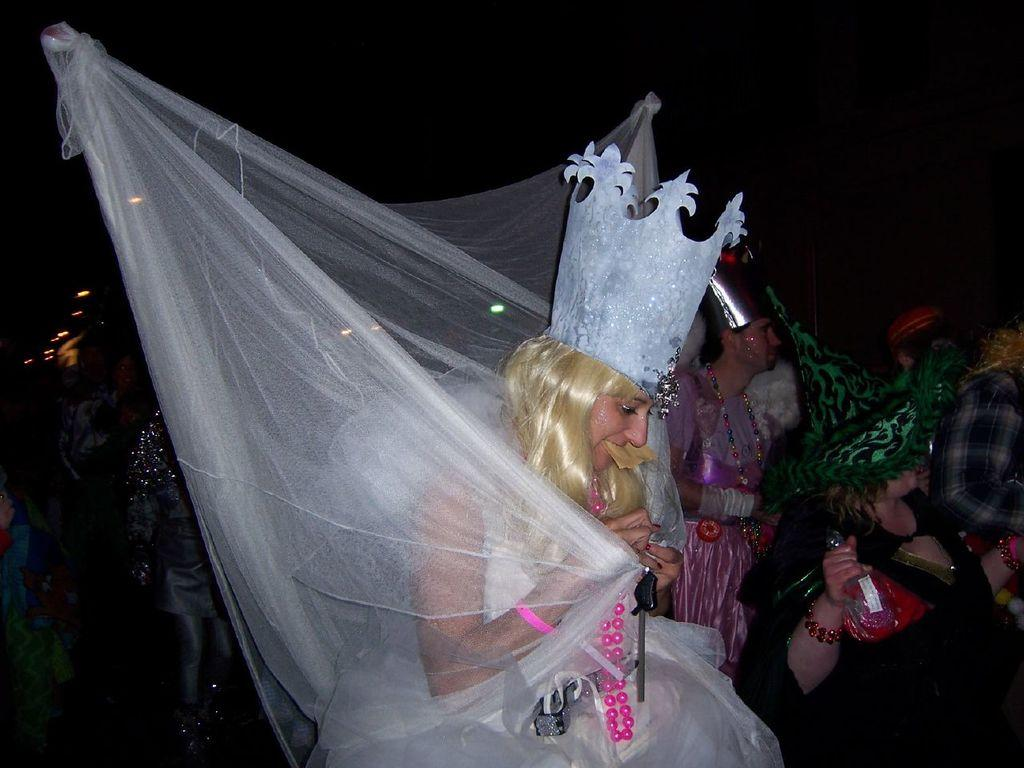How many people are in the image? There is a group of persons in the image. What are some of the persons doing in the image? Some of the persons are holding objects. What can be seen on the left side of the image? There are lights on the left side of the image. How would you describe the overall lighting in the image? The background of the image is dark. What book is the person reading in the image? There is no book present in the image, and no one is shown reading. 